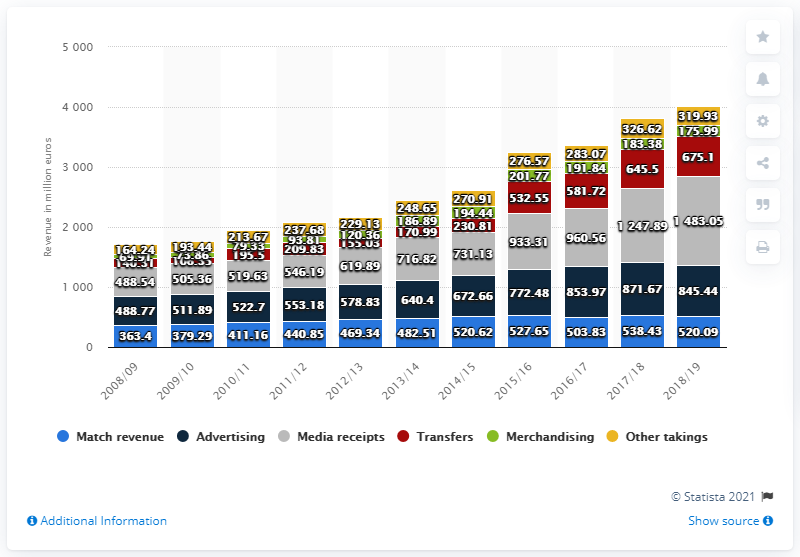Highlight a few significant elements in this photo. The revenue generated from merchandising in the 2018/19 season was 175.99. 